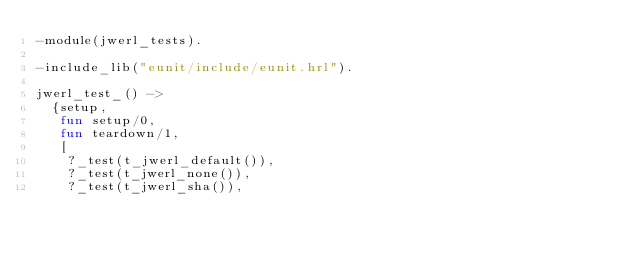<code> <loc_0><loc_0><loc_500><loc_500><_Erlang_>-module(jwerl_tests).

-include_lib("eunit/include/eunit.hrl").

jwerl_test_() ->
  {setup,
   fun setup/0,
   fun teardown/1,
   [
    ?_test(t_jwerl_default()),
    ?_test(t_jwerl_none()),
    ?_test(t_jwerl_sha()),</code> 